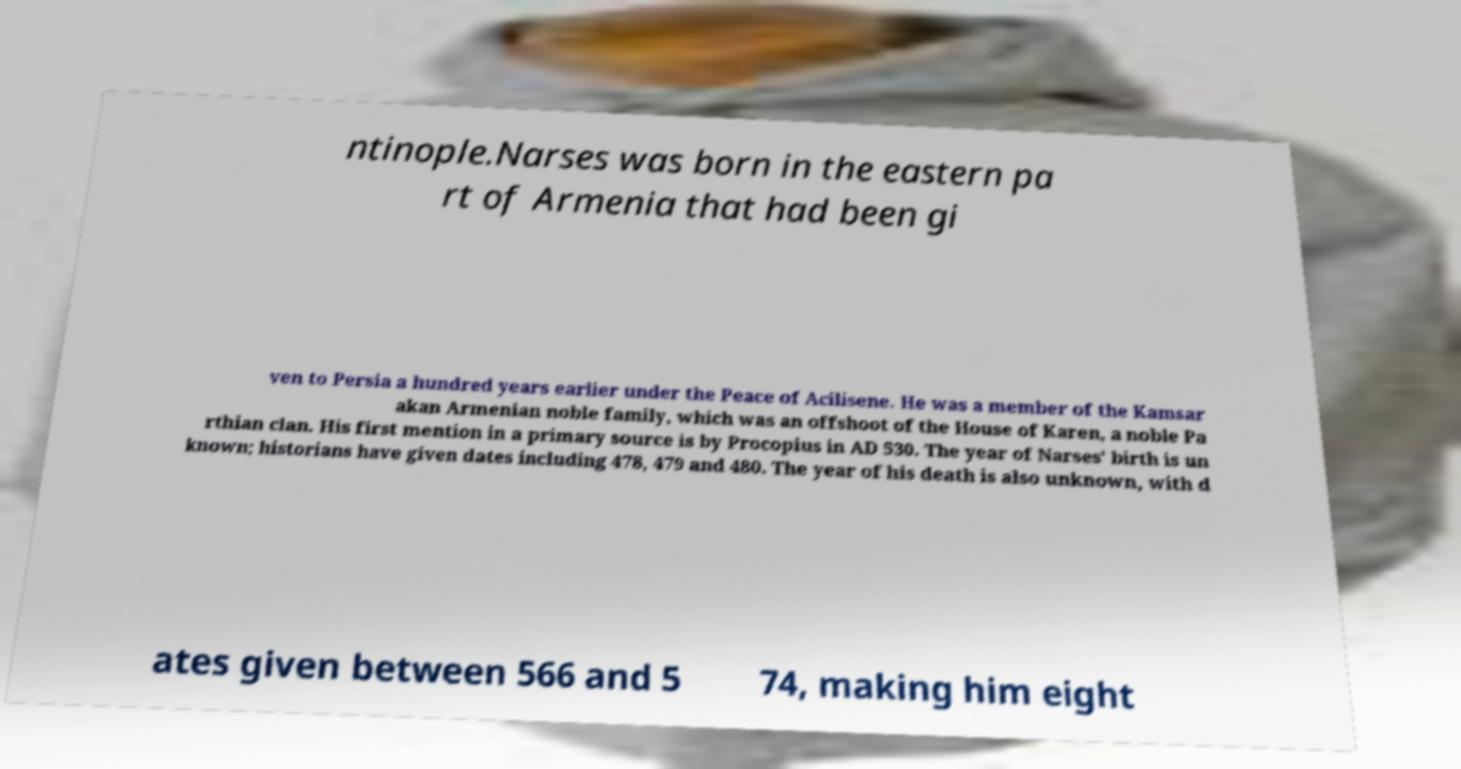Please read and relay the text visible in this image. What does it say? ntinople.Narses was born in the eastern pa rt of Armenia that had been gi ven to Persia a hundred years earlier under the Peace of Acilisene. He was a member of the Kamsar akan Armenian noble family, which was an offshoot of the House of Karen, a noble Pa rthian clan. His first mention in a primary source is by Procopius in AD 530. The year of Narses' birth is un known; historians have given dates including 478, 479 and 480. The year of his death is also unknown, with d ates given between 566 and 5 74, making him eight 